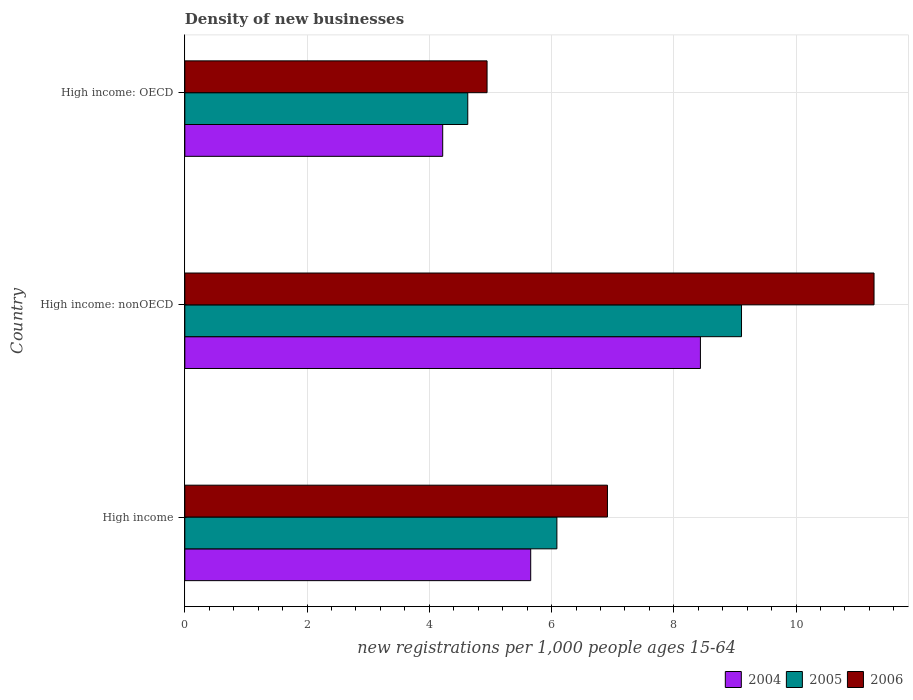Are the number of bars per tick equal to the number of legend labels?
Your response must be concise. Yes. How many bars are there on the 2nd tick from the top?
Provide a succinct answer. 3. How many bars are there on the 2nd tick from the bottom?
Offer a terse response. 3. What is the label of the 1st group of bars from the top?
Your answer should be compact. High income: OECD. In how many cases, is the number of bars for a given country not equal to the number of legend labels?
Make the answer very short. 0. What is the number of new registrations in 2004 in High income?
Your response must be concise. 5.66. Across all countries, what is the maximum number of new registrations in 2005?
Provide a succinct answer. 9.11. Across all countries, what is the minimum number of new registrations in 2005?
Make the answer very short. 4.63. In which country was the number of new registrations in 2005 maximum?
Your answer should be compact. High income: nonOECD. In which country was the number of new registrations in 2006 minimum?
Give a very brief answer. High income: OECD. What is the total number of new registrations in 2004 in the graph?
Make the answer very short. 18.31. What is the difference between the number of new registrations in 2006 in High income and that in High income: OECD?
Give a very brief answer. 1.97. What is the difference between the number of new registrations in 2005 in High income and the number of new registrations in 2006 in High income: nonOECD?
Give a very brief answer. -5.19. What is the average number of new registrations in 2006 per country?
Offer a very short reply. 7.71. What is the difference between the number of new registrations in 2005 and number of new registrations in 2006 in High income: OECD?
Provide a short and direct response. -0.32. In how many countries, is the number of new registrations in 2004 greater than 0.8 ?
Offer a terse response. 3. What is the ratio of the number of new registrations in 2006 in High income to that in High income: OECD?
Your answer should be compact. 1.4. Is the number of new registrations in 2005 in High income less than that in High income: OECD?
Provide a succinct answer. No. What is the difference between the highest and the second highest number of new registrations in 2006?
Your response must be concise. 4.36. What is the difference between the highest and the lowest number of new registrations in 2005?
Make the answer very short. 4.48. In how many countries, is the number of new registrations in 2005 greater than the average number of new registrations in 2005 taken over all countries?
Provide a short and direct response. 1. Is the sum of the number of new registrations in 2006 in High income and High income: OECD greater than the maximum number of new registrations in 2005 across all countries?
Provide a succinct answer. Yes. Is it the case that in every country, the sum of the number of new registrations in 2006 and number of new registrations in 2004 is greater than the number of new registrations in 2005?
Your answer should be compact. Yes. How many countries are there in the graph?
Your answer should be compact. 3. What is the difference between two consecutive major ticks on the X-axis?
Make the answer very short. 2. Are the values on the major ticks of X-axis written in scientific E-notation?
Make the answer very short. No. Does the graph contain grids?
Offer a terse response. Yes. Where does the legend appear in the graph?
Your answer should be compact. Bottom right. How many legend labels are there?
Offer a very short reply. 3. What is the title of the graph?
Give a very brief answer. Density of new businesses. Does "1981" appear as one of the legend labels in the graph?
Offer a terse response. No. What is the label or title of the X-axis?
Your answer should be very brief. New registrations per 1,0 people ages 15-64. What is the label or title of the Y-axis?
Your answer should be compact. Country. What is the new registrations per 1,000 people ages 15-64 in 2004 in High income?
Offer a terse response. 5.66. What is the new registrations per 1,000 people ages 15-64 in 2005 in High income?
Provide a succinct answer. 6.09. What is the new registrations per 1,000 people ages 15-64 in 2006 in High income?
Keep it short and to the point. 6.91. What is the new registrations per 1,000 people ages 15-64 in 2004 in High income: nonOECD?
Make the answer very short. 8.44. What is the new registrations per 1,000 people ages 15-64 in 2005 in High income: nonOECD?
Your response must be concise. 9.11. What is the new registrations per 1,000 people ages 15-64 in 2006 in High income: nonOECD?
Keep it short and to the point. 11.28. What is the new registrations per 1,000 people ages 15-64 of 2004 in High income: OECD?
Offer a very short reply. 4.22. What is the new registrations per 1,000 people ages 15-64 in 2005 in High income: OECD?
Keep it short and to the point. 4.63. What is the new registrations per 1,000 people ages 15-64 in 2006 in High income: OECD?
Offer a terse response. 4.94. Across all countries, what is the maximum new registrations per 1,000 people ages 15-64 in 2004?
Provide a short and direct response. 8.44. Across all countries, what is the maximum new registrations per 1,000 people ages 15-64 of 2005?
Offer a very short reply. 9.11. Across all countries, what is the maximum new registrations per 1,000 people ages 15-64 of 2006?
Make the answer very short. 11.28. Across all countries, what is the minimum new registrations per 1,000 people ages 15-64 in 2004?
Give a very brief answer. 4.22. Across all countries, what is the minimum new registrations per 1,000 people ages 15-64 in 2005?
Your answer should be compact. 4.63. Across all countries, what is the minimum new registrations per 1,000 people ages 15-64 in 2006?
Your answer should be very brief. 4.94. What is the total new registrations per 1,000 people ages 15-64 in 2004 in the graph?
Keep it short and to the point. 18.31. What is the total new registrations per 1,000 people ages 15-64 of 2005 in the graph?
Keep it short and to the point. 19.82. What is the total new registrations per 1,000 people ages 15-64 in 2006 in the graph?
Your answer should be very brief. 23.14. What is the difference between the new registrations per 1,000 people ages 15-64 in 2004 in High income and that in High income: nonOECD?
Keep it short and to the point. -2.78. What is the difference between the new registrations per 1,000 people ages 15-64 of 2005 in High income and that in High income: nonOECD?
Offer a very short reply. -3.02. What is the difference between the new registrations per 1,000 people ages 15-64 of 2006 in High income and that in High income: nonOECD?
Make the answer very short. -4.36. What is the difference between the new registrations per 1,000 people ages 15-64 in 2004 in High income and that in High income: OECD?
Ensure brevity in your answer.  1.44. What is the difference between the new registrations per 1,000 people ages 15-64 in 2005 in High income and that in High income: OECD?
Make the answer very short. 1.46. What is the difference between the new registrations per 1,000 people ages 15-64 of 2006 in High income and that in High income: OECD?
Give a very brief answer. 1.97. What is the difference between the new registrations per 1,000 people ages 15-64 of 2004 in High income: nonOECD and that in High income: OECD?
Keep it short and to the point. 4.22. What is the difference between the new registrations per 1,000 people ages 15-64 in 2005 in High income: nonOECD and that in High income: OECD?
Offer a terse response. 4.48. What is the difference between the new registrations per 1,000 people ages 15-64 of 2006 in High income: nonOECD and that in High income: OECD?
Provide a short and direct response. 6.33. What is the difference between the new registrations per 1,000 people ages 15-64 in 2004 in High income and the new registrations per 1,000 people ages 15-64 in 2005 in High income: nonOECD?
Offer a terse response. -3.45. What is the difference between the new registrations per 1,000 people ages 15-64 of 2004 in High income and the new registrations per 1,000 people ages 15-64 of 2006 in High income: nonOECD?
Make the answer very short. -5.62. What is the difference between the new registrations per 1,000 people ages 15-64 in 2005 in High income and the new registrations per 1,000 people ages 15-64 in 2006 in High income: nonOECD?
Make the answer very short. -5.19. What is the difference between the new registrations per 1,000 people ages 15-64 of 2004 in High income and the new registrations per 1,000 people ages 15-64 of 2005 in High income: OECD?
Your answer should be compact. 1.03. What is the difference between the new registrations per 1,000 people ages 15-64 of 2004 in High income and the new registrations per 1,000 people ages 15-64 of 2006 in High income: OECD?
Make the answer very short. 0.71. What is the difference between the new registrations per 1,000 people ages 15-64 of 2005 in High income and the new registrations per 1,000 people ages 15-64 of 2006 in High income: OECD?
Provide a short and direct response. 1.14. What is the difference between the new registrations per 1,000 people ages 15-64 of 2004 in High income: nonOECD and the new registrations per 1,000 people ages 15-64 of 2005 in High income: OECD?
Keep it short and to the point. 3.81. What is the difference between the new registrations per 1,000 people ages 15-64 of 2004 in High income: nonOECD and the new registrations per 1,000 people ages 15-64 of 2006 in High income: OECD?
Provide a short and direct response. 3.49. What is the difference between the new registrations per 1,000 people ages 15-64 of 2005 in High income: nonOECD and the new registrations per 1,000 people ages 15-64 of 2006 in High income: OECD?
Your answer should be compact. 4.16. What is the average new registrations per 1,000 people ages 15-64 of 2004 per country?
Provide a succinct answer. 6.1. What is the average new registrations per 1,000 people ages 15-64 of 2005 per country?
Offer a very short reply. 6.61. What is the average new registrations per 1,000 people ages 15-64 in 2006 per country?
Give a very brief answer. 7.71. What is the difference between the new registrations per 1,000 people ages 15-64 in 2004 and new registrations per 1,000 people ages 15-64 in 2005 in High income?
Your response must be concise. -0.43. What is the difference between the new registrations per 1,000 people ages 15-64 in 2004 and new registrations per 1,000 people ages 15-64 in 2006 in High income?
Offer a terse response. -1.26. What is the difference between the new registrations per 1,000 people ages 15-64 of 2005 and new registrations per 1,000 people ages 15-64 of 2006 in High income?
Ensure brevity in your answer.  -0.83. What is the difference between the new registrations per 1,000 people ages 15-64 in 2004 and new registrations per 1,000 people ages 15-64 in 2005 in High income: nonOECD?
Keep it short and to the point. -0.67. What is the difference between the new registrations per 1,000 people ages 15-64 of 2004 and new registrations per 1,000 people ages 15-64 of 2006 in High income: nonOECD?
Provide a short and direct response. -2.84. What is the difference between the new registrations per 1,000 people ages 15-64 in 2005 and new registrations per 1,000 people ages 15-64 in 2006 in High income: nonOECD?
Make the answer very short. -2.17. What is the difference between the new registrations per 1,000 people ages 15-64 in 2004 and new registrations per 1,000 people ages 15-64 in 2005 in High income: OECD?
Your response must be concise. -0.41. What is the difference between the new registrations per 1,000 people ages 15-64 in 2004 and new registrations per 1,000 people ages 15-64 in 2006 in High income: OECD?
Offer a very short reply. -0.73. What is the difference between the new registrations per 1,000 people ages 15-64 of 2005 and new registrations per 1,000 people ages 15-64 of 2006 in High income: OECD?
Ensure brevity in your answer.  -0.32. What is the ratio of the new registrations per 1,000 people ages 15-64 of 2004 in High income to that in High income: nonOECD?
Your answer should be very brief. 0.67. What is the ratio of the new registrations per 1,000 people ages 15-64 in 2005 in High income to that in High income: nonOECD?
Give a very brief answer. 0.67. What is the ratio of the new registrations per 1,000 people ages 15-64 of 2006 in High income to that in High income: nonOECD?
Your response must be concise. 0.61. What is the ratio of the new registrations per 1,000 people ages 15-64 of 2004 in High income to that in High income: OECD?
Provide a short and direct response. 1.34. What is the ratio of the new registrations per 1,000 people ages 15-64 in 2005 in High income to that in High income: OECD?
Make the answer very short. 1.31. What is the ratio of the new registrations per 1,000 people ages 15-64 of 2006 in High income to that in High income: OECD?
Ensure brevity in your answer.  1.4. What is the ratio of the new registrations per 1,000 people ages 15-64 in 2004 in High income: nonOECD to that in High income: OECD?
Your response must be concise. 2. What is the ratio of the new registrations per 1,000 people ages 15-64 of 2005 in High income: nonOECD to that in High income: OECD?
Give a very brief answer. 1.97. What is the ratio of the new registrations per 1,000 people ages 15-64 of 2006 in High income: nonOECD to that in High income: OECD?
Provide a succinct answer. 2.28. What is the difference between the highest and the second highest new registrations per 1,000 people ages 15-64 in 2004?
Give a very brief answer. 2.78. What is the difference between the highest and the second highest new registrations per 1,000 people ages 15-64 in 2005?
Ensure brevity in your answer.  3.02. What is the difference between the highest and the second highest new registrations per 1,000 people ages 15-64 in 2006?
Offer a terse response. 4.36. What is the difference between the highest and the lowest new registrations per 1,000 people ages 15-64 in 2004?
Keep it short and to the point. 4.22. What is the difference between the highest and the lowest new registrations per 1,000 people ages 15-64 in 2005?
Give a very brief answer. 4.48. What is the difference between the highest and the lowest new registrations per 1,000 people ages 15-64 of 2006?
Provide a succinct answer. 6.33. 